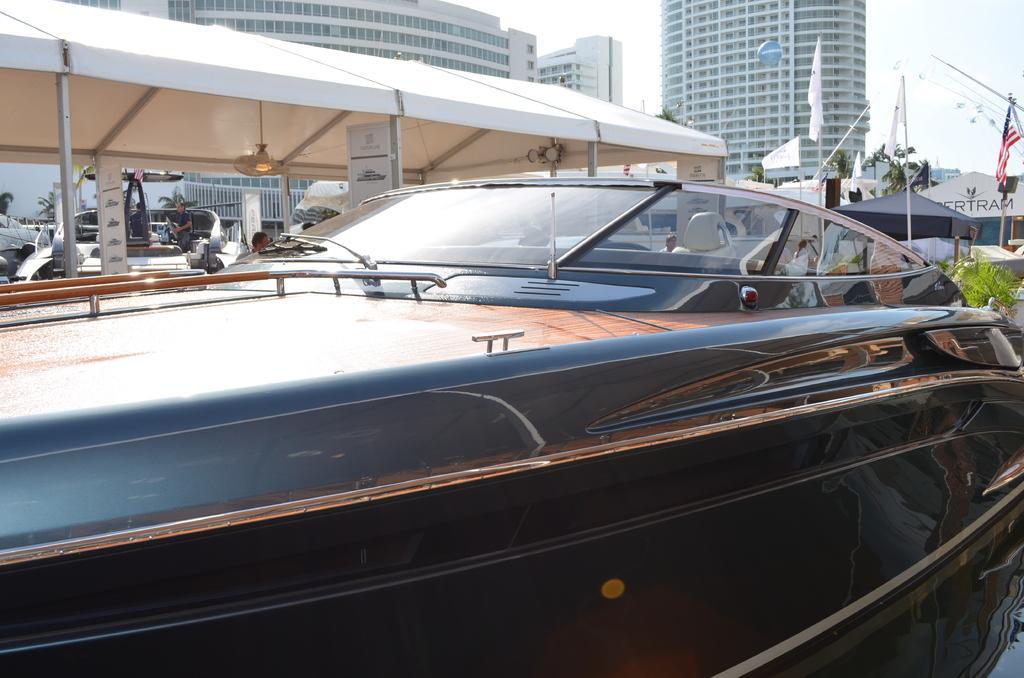Please provide a concise description of this image. In this image we can see a few people, there are buildings, there are sheds, there are plants, trees, there are boards with text on them, there is a vehicle, a light, also we can see the flag, and the sky. 